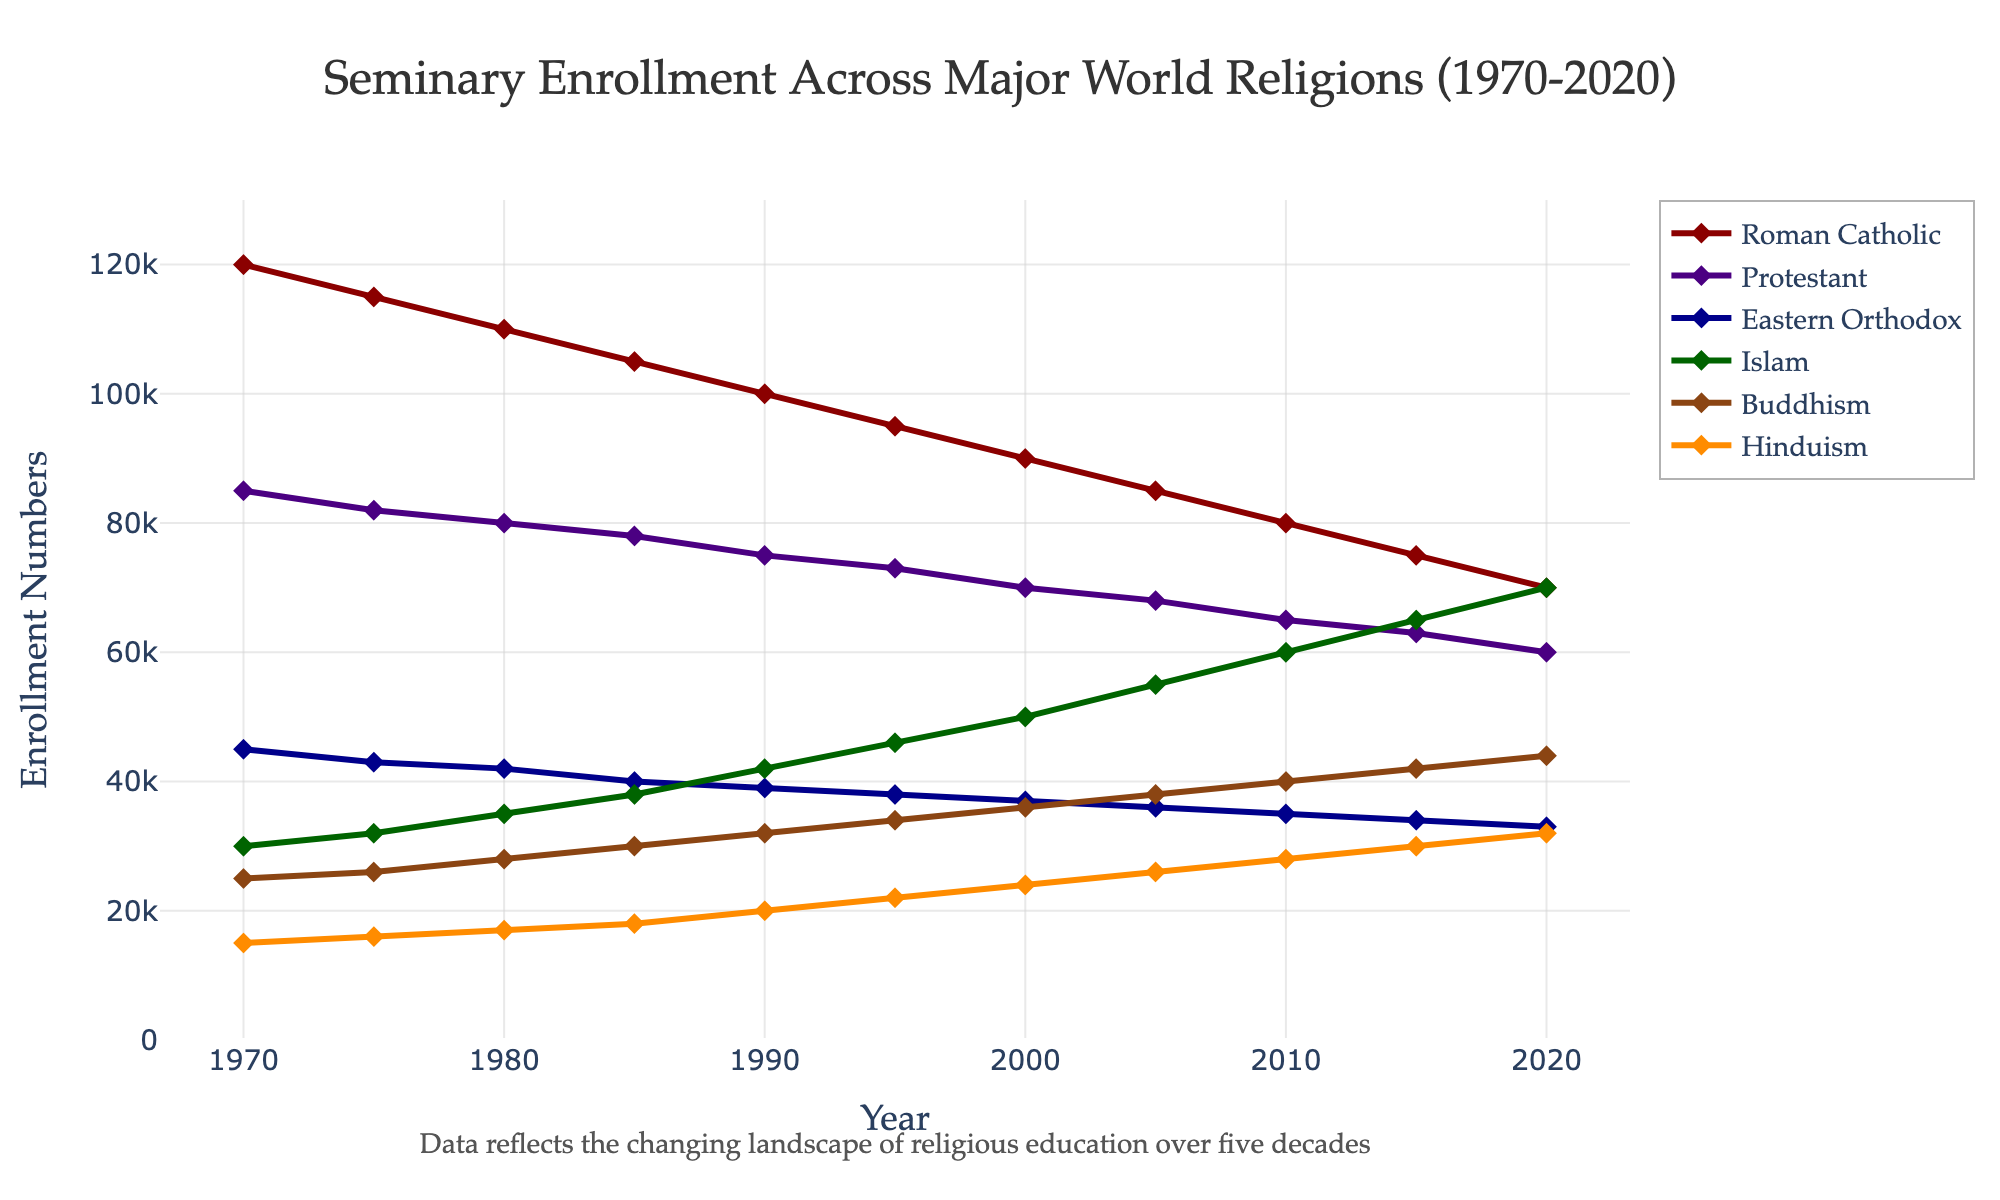How has Roman Catholic seminary enrollment numbers changed from 1970 to 2020? The Roman Catholic enrollment in 1970 was 120,000 and in 2020 it was 70,000. To find the change, subtract the 2020 number from the 1970 number: 120,000 - 70,000 = 50,000.
Answer: Decreased by 50,000 Which religion saw the most significant increase in seminary enrollment between 1970 and 2020? Compare the enrollment numbers for all religions in 1970 and 2020. Islam increased from 30,000 in 1970 to 70,000 in 2020, a difference of 40,000. This is the largest increase among all religions.
Answer: Islam In which decade did Protestant seminary enrollment experience the smallest decline? Look at the Protestant enrollment numbers for each decade: 1970–1980: 85,000 to 80,000 (-5,000); 1980–1990: 80,000 to 75,000 (-5,000); 1990–2000: 75,000 to 70,000 (-5,000); 2000–2010: 70,000 to 65,000 (-5,000); and 2010–2020: 65,000 to 60,000 (-5,000). The decline was consistent at 5,000 per decade, so no decade had a smaller decline.
Answer: Consistent decline of 5,000 per decade What is the average seminary enrollment for Buddhism from 1970 to 2020? Sum the Buddhist enrollment numbers and divide by the number of years (10). (25,000 + 26,000 + 28,000 + 30,000 + 32,000 + 34,000 + 36,000 + 38,000 + 40,000 + 42,000 + 44,000) / 10 = 34,100.
Answer: 34,100 How did Hindu seminary enrollments change in comparison to Eastern Orthodox between 1970 and 2020? Calculate the enrollment change for both religions. Hinduism: 32,000 - 15,000 = 17,000 increase; Eastern Orthodox: 33,000 - 45,000 = 12,000 decrease.
Answer: Hinduism increased by 17,000, Orthodox decreased by 12,000 Which religion had the least fluctuation in enrolling numbers over the 50 years? Compare the highest and lowest enrollment numbers for each religion over the time period. The religion with the smallest difference between these numbers had the least fluctuation. Hinduism: peak (32,000) - low (15,000) = 17,000; Protestantism: peak (85,000) - low (60,000) = 25,000. Hinduism had the least fluctuation.
Answer: Hinduism During which decade did Islamic seminary enrollment surpass Protestant enrollment? Islamic enrollment surpassed Protestant enrollment between 2005 and 2010. In 2010, Protestant was 65,000 and Islam was 60,000. In 2015, Protestant was 63,000 and Islam was 65,000. So, the change happened between 2010 and 2015.
Answer: 2010-2015 